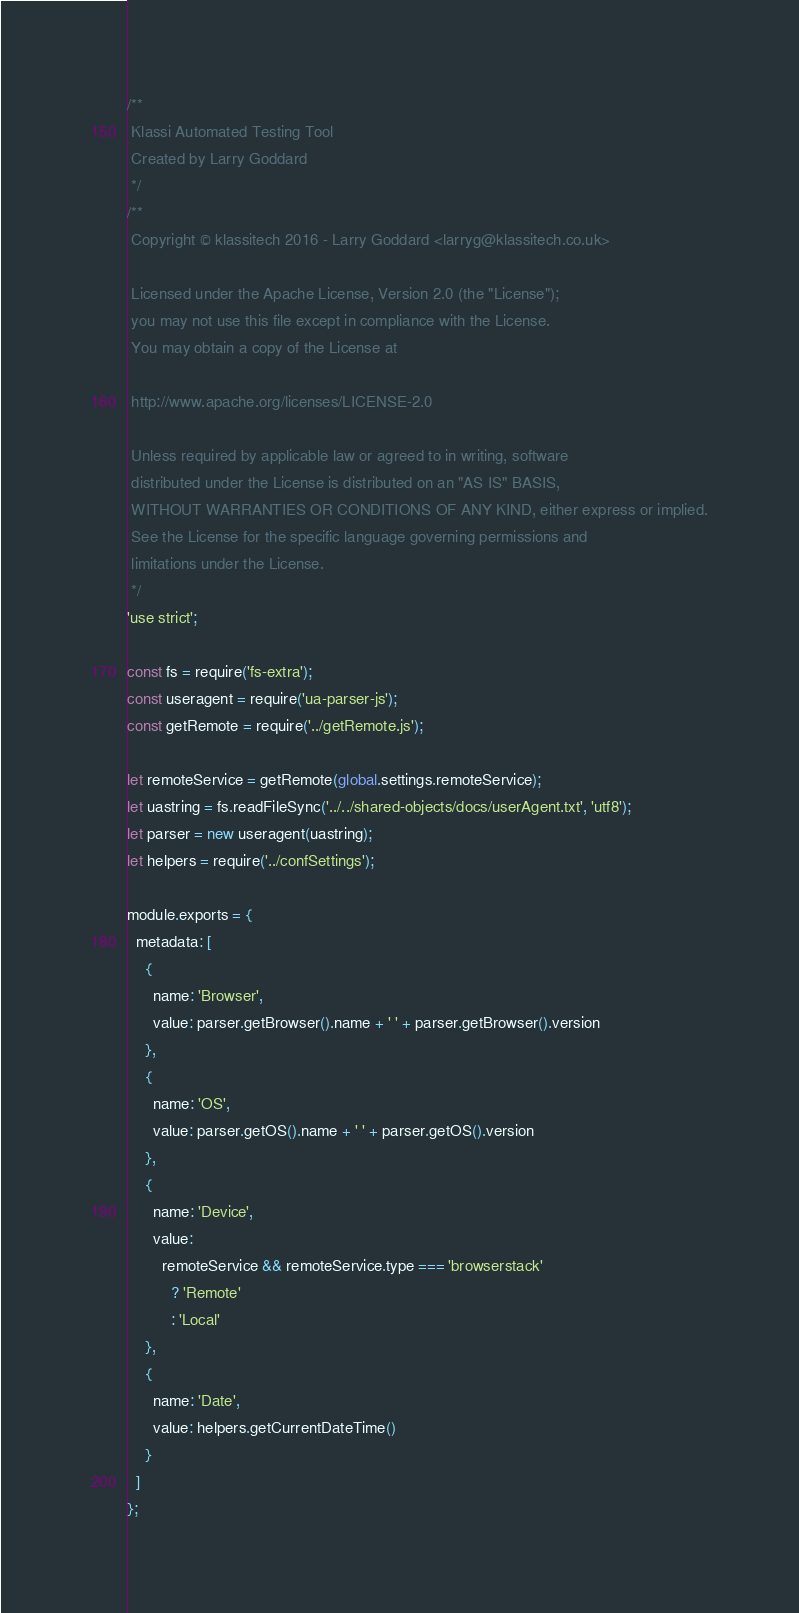Convert code to text. <code><loc_0><loc_0><loc_500><loc_500><_JavaScript_>/**
 Klassi Automated Testing Tool
 Created by Larry Goddard
 */
/**
 Copyright © klassitech 2016 - Larry Goddard <larryg@klassitech.co.uk>

 Licensed under the Apache License, Version 2.0 (the "License");
 you may not use this file except in compliance with the License.
 You may obtain a copy of the License at

 http://www.apache.org/licenses/LICENSE-2.0

 Unless required by applicable law or agreed to in writing, software
 distributed under the License is distributed on an "AS IS" BASIS,
 WITHOUT WARRANTIES OR CONDITIONS OF ANY KIND, either express or implied.
 See the License for the specific language governing permissions and
 limitations under the License.
 */
'use strict';

const fs = require('fs-extra');
const useragent = require('ua-parser-js');
const getRemote = require('../getRemote.js');

let remoteService = getRemote(global.settings.remoteService);
let uastring = fs.readFileSync('../../shared-objects/docs/userAgent.txt', 'utf8');
let parser = new useragent(uastring);
let helpers = require('../confSettings');

module.exports = {
  metadata: [
    {
      name: 'Browser',
      value: parser.getBrowser().name + ' ' + parser.getBrowser().version
    },
    {
      name: 'OS',
      value: parser.getOS().name + ' ' + parser.getOS().version
    },
    {
      name: 'Device',
      value:
        remoteService && remoteService.type === 'browserstack'
          ? 'Remote'
          : 'Local'
    },
    {
      name: 'Date',
      value: helpers.getCurrentDateTime()
    }
  ]
};
</code> 